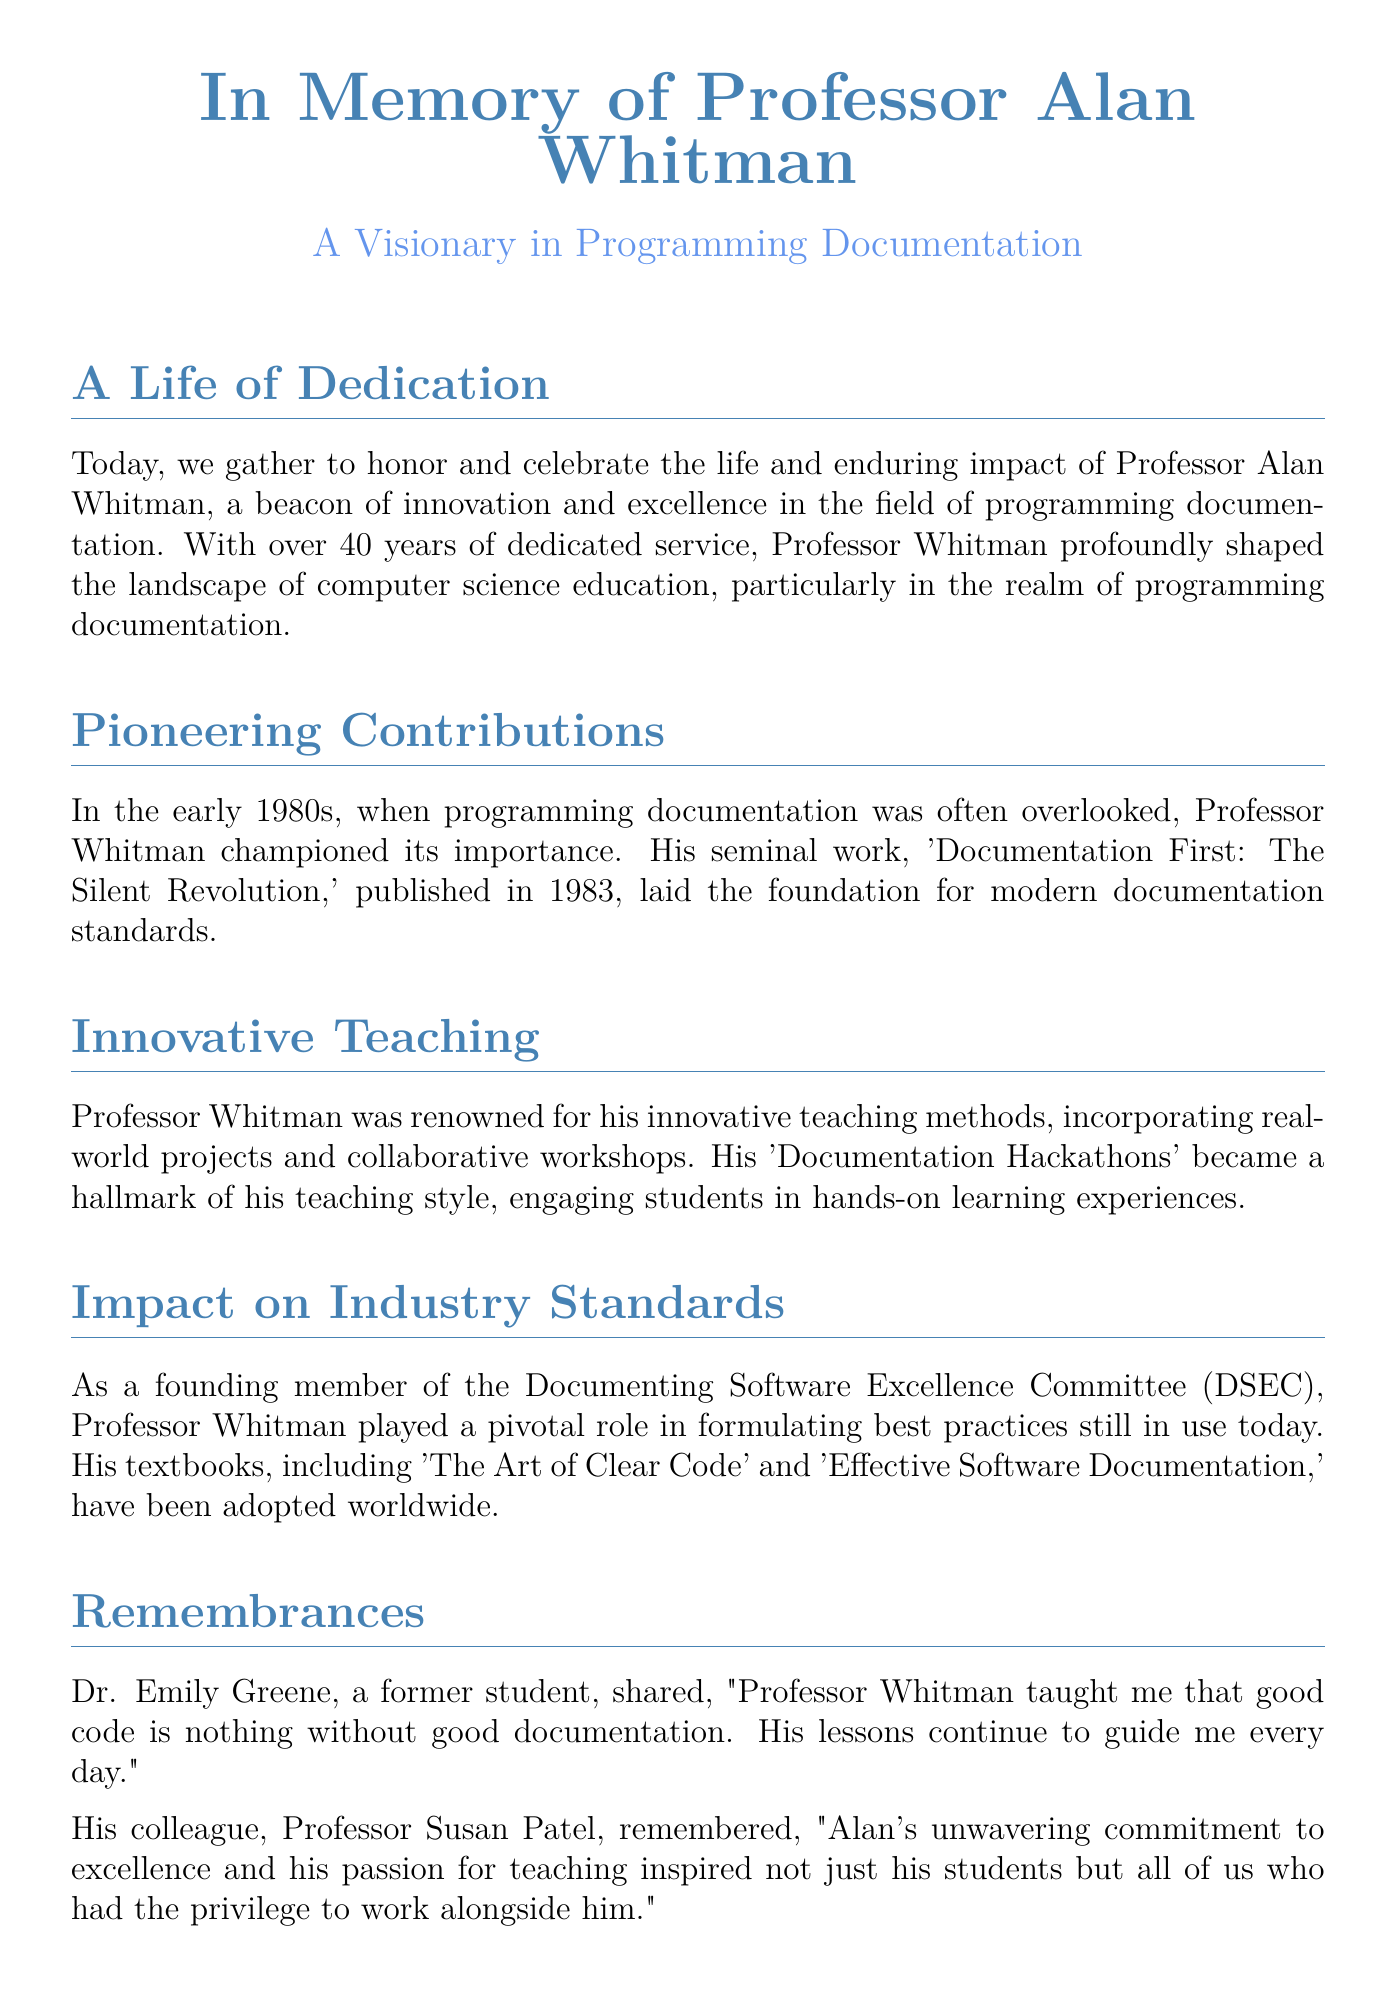What is the full name of the professor being honored? The document states that the professor's full name is Professor Alan Whitman.
Answer: Professor Alan Whitman What significant work did Professor Whitman publish in 1983? The document mentions the seminal work titled 'Documentation First: The Silent Revolution' published in 1983.
Answer: 'Documentation First: The Silent Revolution' What innovative teaching method did Professor Whitman use? The document describes 'Documentation Hackathons' as a hallmark of Professor Whitman's teaching style.
Answer: Documentation Hackathons What committee did Professor Whitman help to found? According to the document, he was a founding member of the Documenting Software Excellence Committee.
Answer: Documenting Software Excellence Committee How many years did Professor Whitman serve in his field? The document states he served for over 40 years.
Answer: Over 40 years What did Dr. Emily Greene say Professor Whitman taught her? The document quotes Dr. Greene, stating that he taught her that good code is nothing without good documentation.
Answer: Good code is nothing without good documentation What kind of projects did Professor Whitman incorporate into his teaching? The document mentions that he incorporated real-world projects and collaborative workshops into his teaching.
Answer: Real-world projects and collaborative workshops What themes are emphasized in the remembrances section? The remembrances highlight commitment to excellence and passion for teaching as key themes.
Answer: Commitment to excellence and passion for teaching 